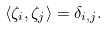<formula> <loc_0><loc_0><loc_500><loc_500>\langle \zeta _ { i } , \zeta _ { j } \rangle & = \delta _ { i , j } .</formula> 